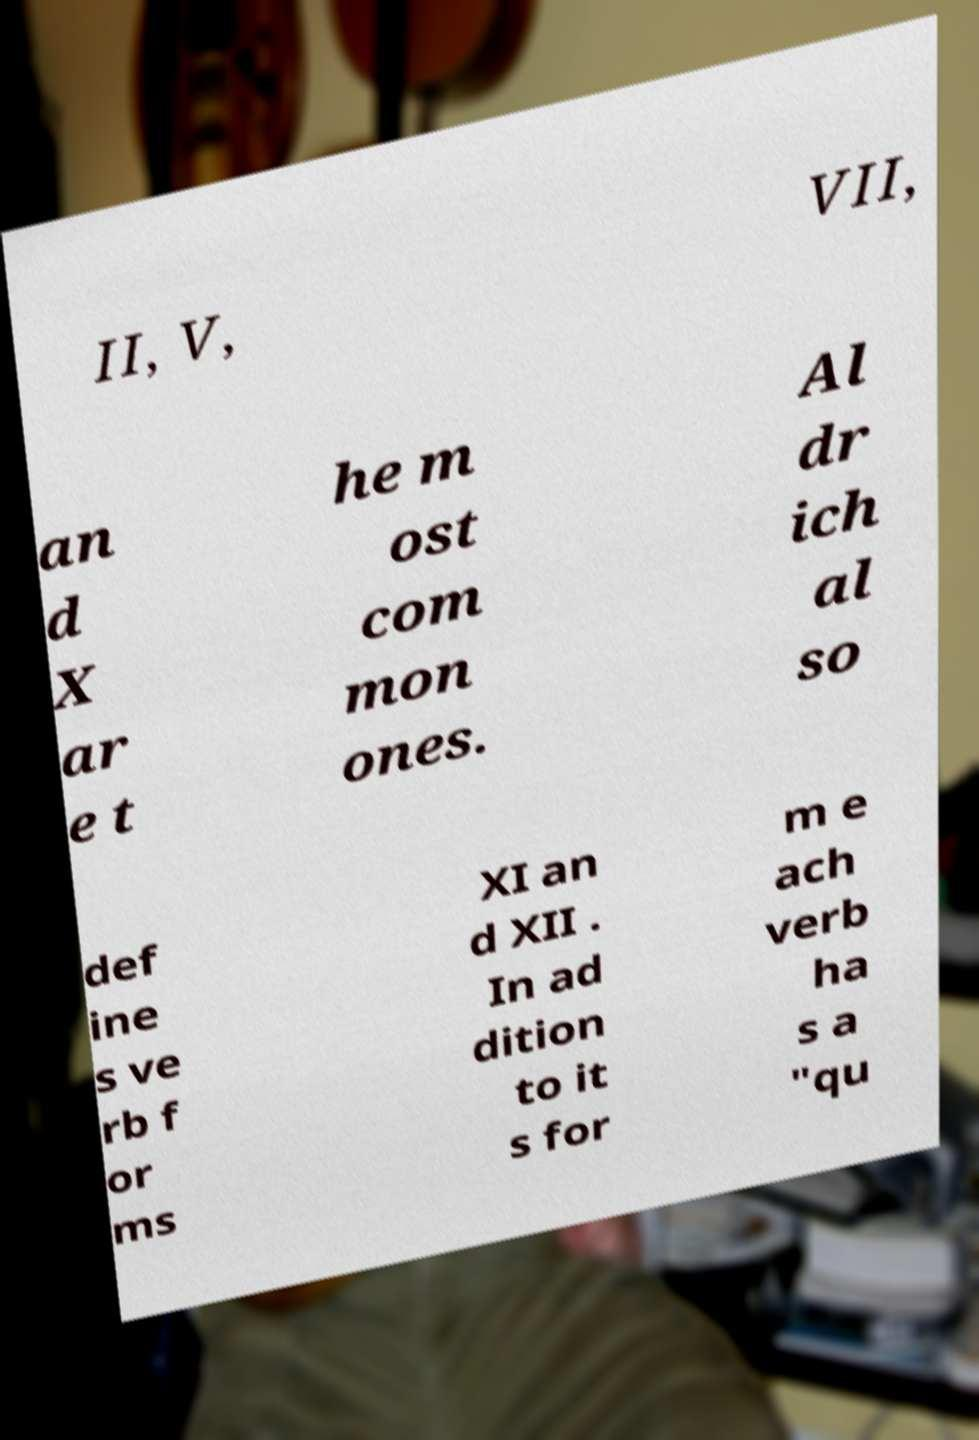Could you assist in decoding the text presented in this image and type it out clearly? II, V, VII, an d X ar e t he m ost com mon ones. Al dr ich al so def ine s ve rb f or ms XI an d XII . In ad dition to it s for m e ach verb ha s a "qu 